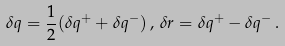<formula> <loc_0><loc_0><loc_500><loc_500>\delta q = \frac { 1 } { 2 } ( \delta q ^ { + } + \delta q ^ { - } ) \, , \, \delta r = \delta q ^ { + } - \delta q ^ { - } \, .</formula> 